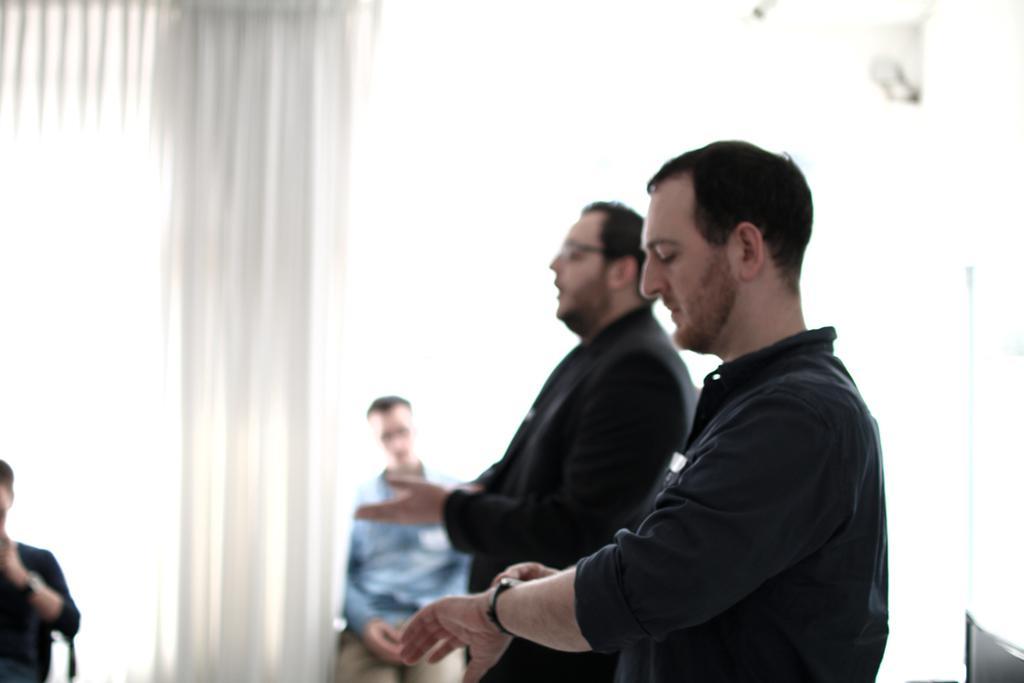Can you describe this image briefly? In this image, we can see three persons wearing clothes on the white background. There is an another person in the bottom left of the image. 